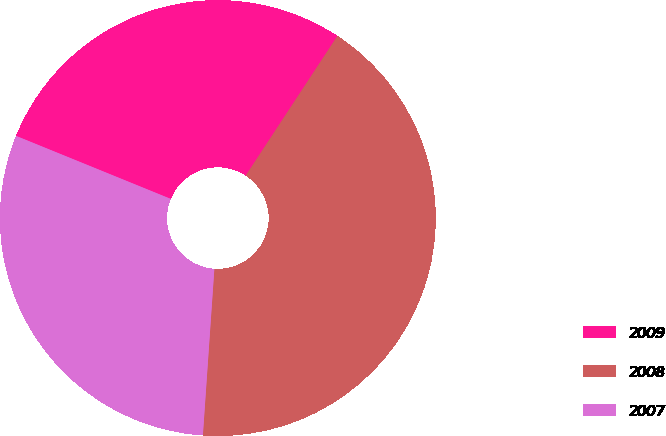Convert chart to OTSL. <chart><loc_0><loc_0><loc_500><loc_500><pie_chart><fcel>2009<fcel>2008<fcel>2007<nl><fcel>28.09%<fcel>41.85%<fcel>30.06%<nl></chart> 